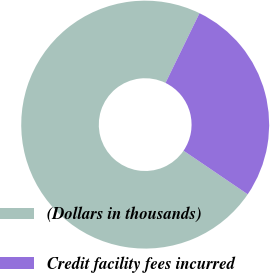Convert chart. <chart><loc_0><loc_0><loc_500><loc_500><pie_chart><fcel>(Dollars in thousands)<fcel>Credit facility fees incurred<nl><fcel>72.72%<fcel>27.28%<nl></chart> 